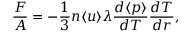Convert formula to latex. <formula><loc_0><loc_0><loc_500><loc_500>\frac { F } { A } = - \frac { 1 } { 3 } n \langle u \rangle \lambda \frac { d \langle p \rangle } { d T } \frac { d T } { d r } ,</formula> 